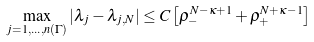<formula> <loc_0><loc_0><loc_500><loc_500>\max _ { j = 1 , \dots , n ( \Gamma ) } | \lambda _ { j } - \lambda _ { j , N } | \leq C \left [ \rho _ { - } ^ { N - \kappa + 1 } + \rho _ { + } ^ { N + \kappa - 1 } \right ]</formula> 